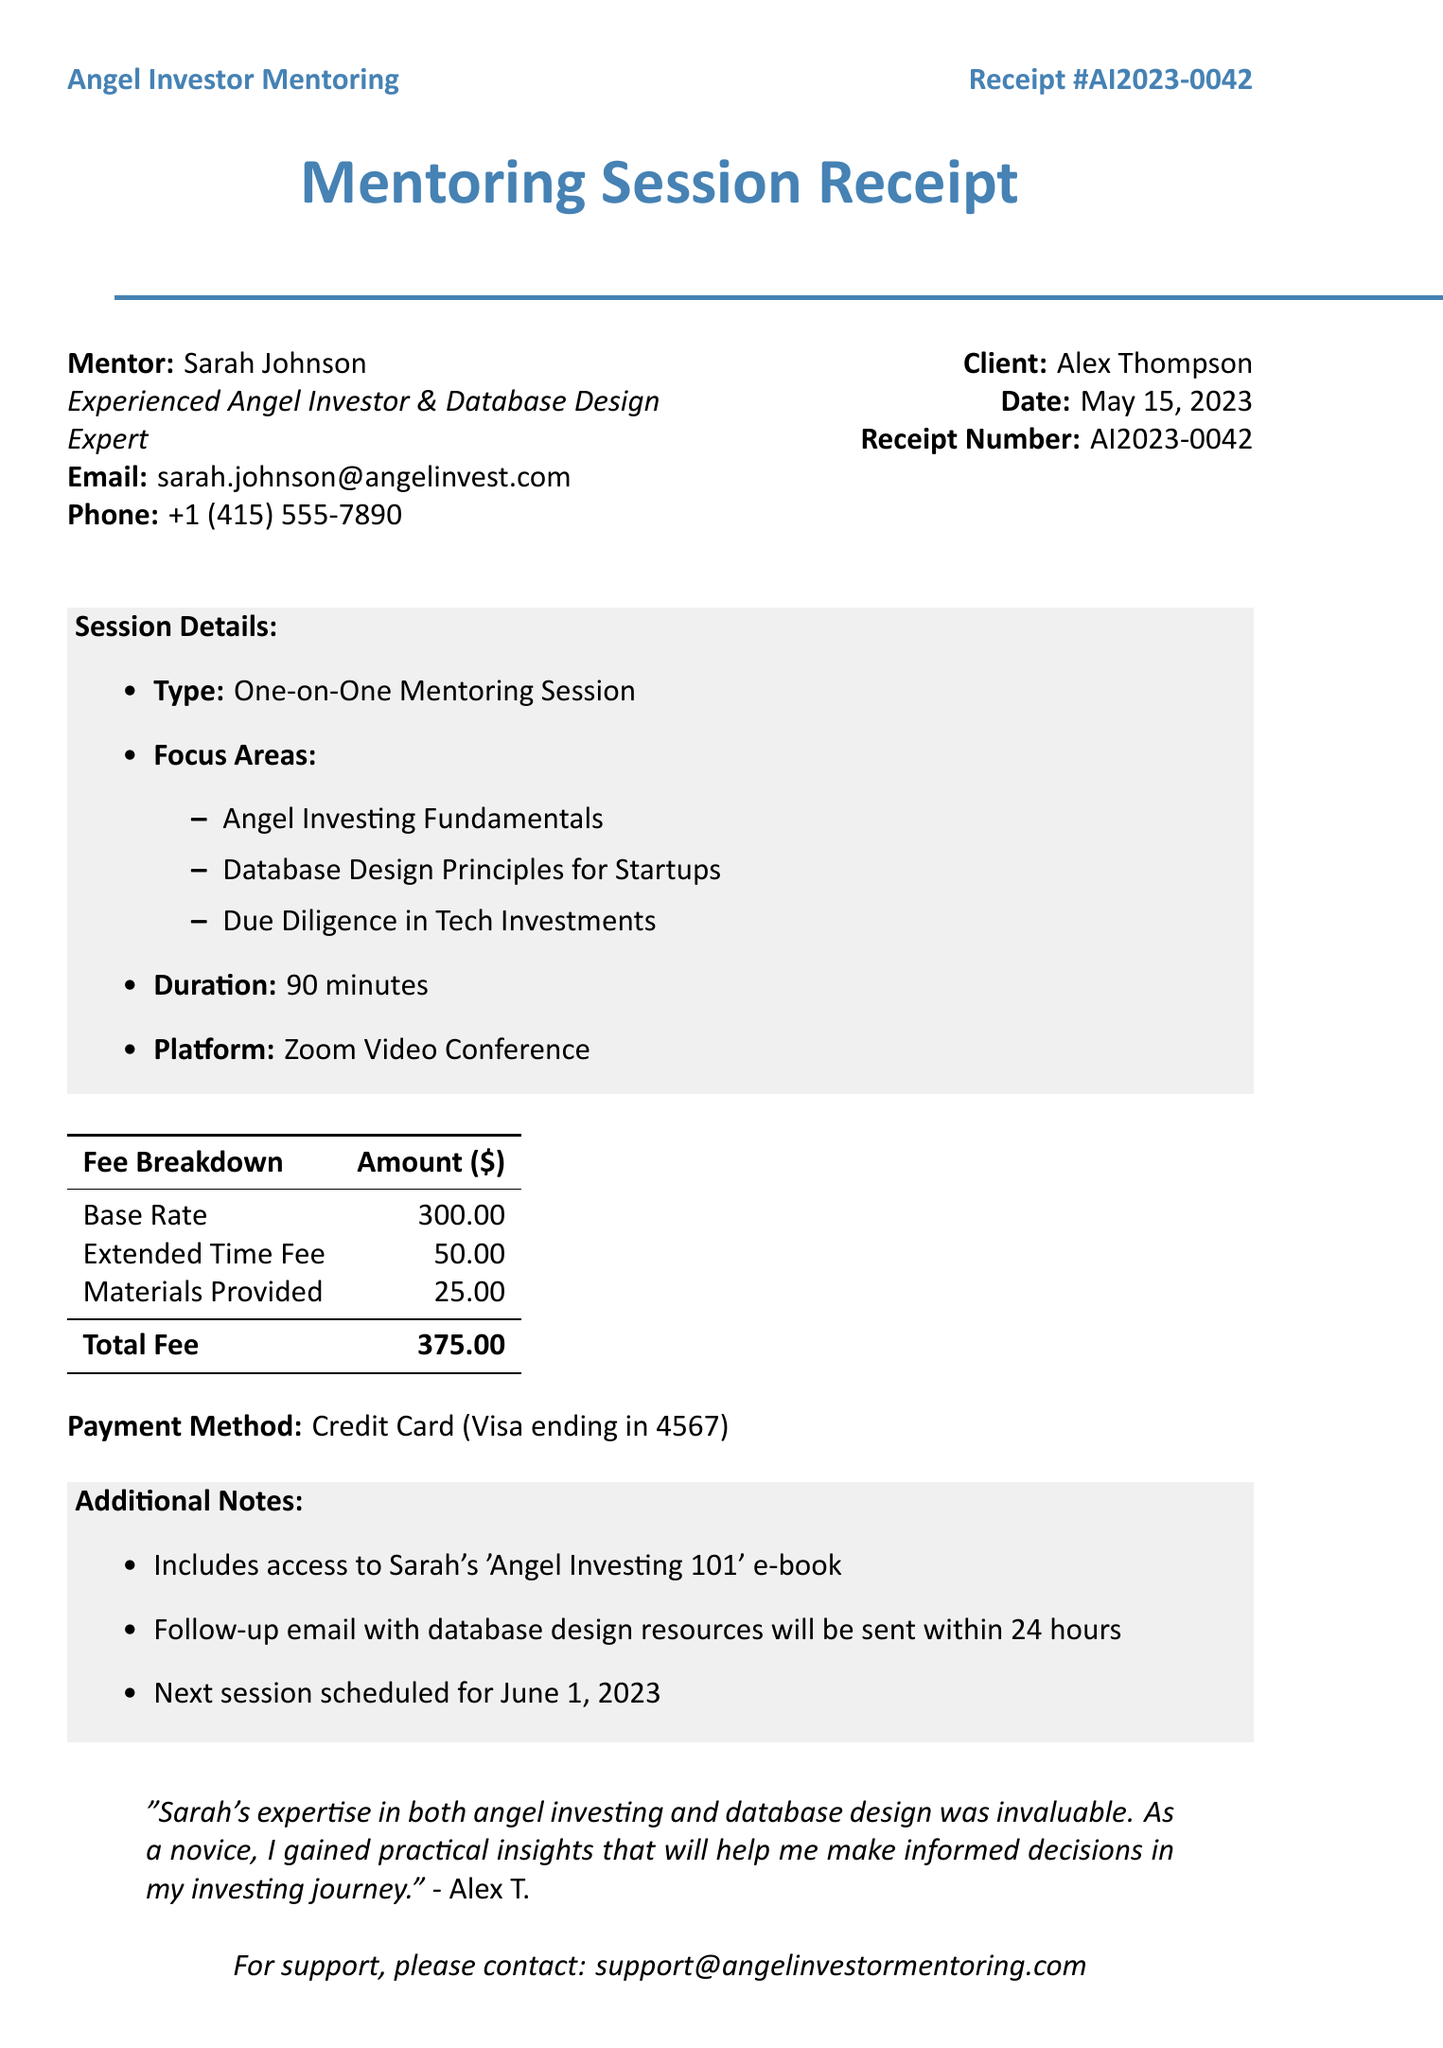What is the receipt number? The receipt number is a unique identifier for the transaction and is listed on the document.
Answer: AI2023-0042 Who is the mentor? The document lists the name of the mentor who provided the session.
Answer: Sarah Johnson What is the duration of the mentoring session? The duration is specified in the session details section of the receipt.
Answer: 90 minutes What is the total fee for the session? The total fee is the final amount charged for the service and is included in the fee breakdown.
Answer: 375 What are the focus areas of the mentoring session? The focus areas highlight the topics covered during the session and are listed under session details.
Answer: Angel Investing Fundamentals, Database Design Principles for Startups, Due Diligence in Tech Investments How was the payment made? The payment method is described in the receipt and states how the client paid for the session.
Answer: Credit Card (Visa ending in 4567) What will be included in the follow-up email? The additional notes mention what the client will receive after the session.
Answer: Database design resources What e-book is included with the session? The additional notes specify the name of the e-book provided to the client as part of the session.
Answer: Angel Investing 101 When is the next session scheduled? The next session date is provided in the additional notes section of the document.
Answer: June 1, 2023 